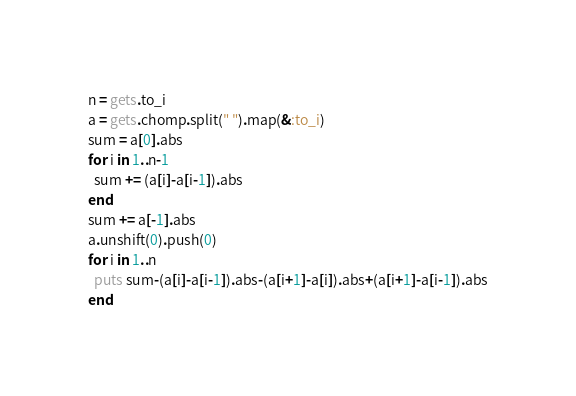Convert code to text. <code><loc_0><loc_0><loc_500><loc_500><_Ruby_>n = gets.to_i
a = gets.chomp.split(" ").map(&:to_i)
sum = a[0].abs
for i in 1..n-1
  sum += (a[i]-a[i-1]).abs
end
sum += a[-1].abs
a.unshift(0).push(0)
for i in 1..n
  puts sum-(a[i]-a[i-1]).abs-(a[i+1]-a[i]).abs+(a[i+1]-a[i-1]).abs
end</code> 